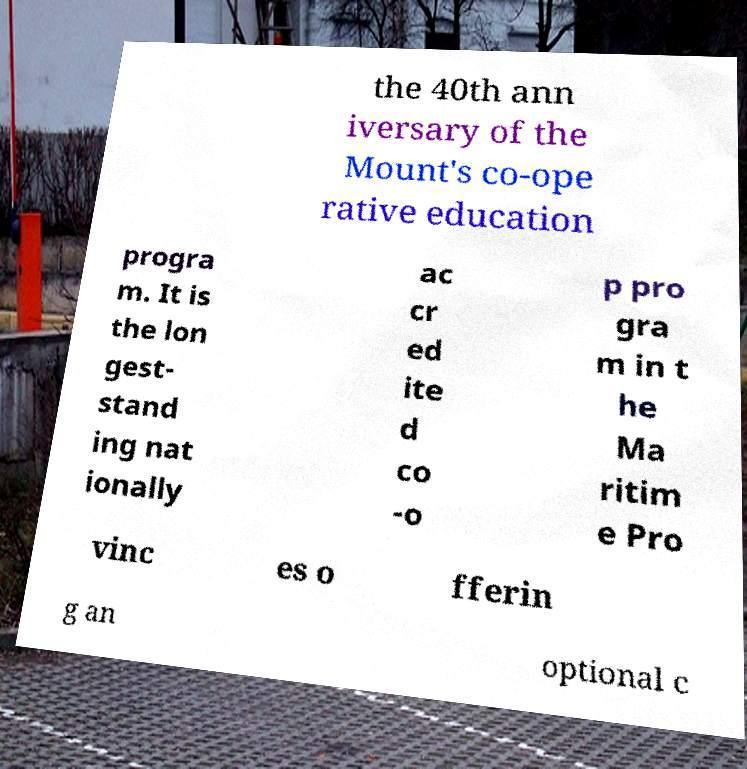Can you accurately transcribe the text from the provided image for me? the 40th ann iversary of the Mount's co-ope rative education progra m. It is the lon gest- stand ing nat ionally ac cr ed ite d co -o p pro gra m in t he Ma ritim e Pro vinc es o fferin g an optional c 